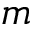<formula> <loc_0><loc_0><loc_500><loc_500>m</formula> 